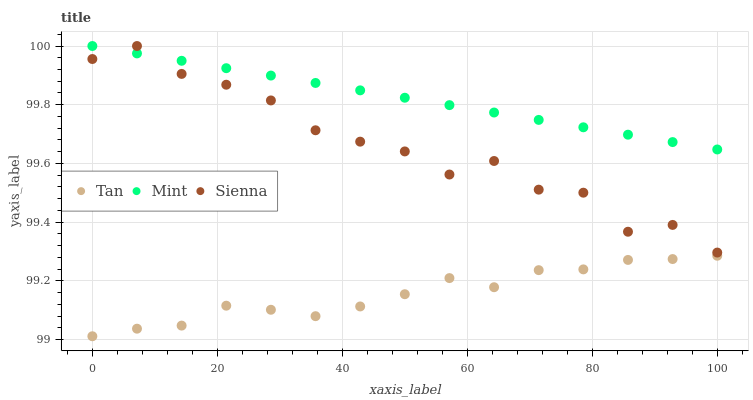Does Tan have the minimum area under the curve?
Answer yes or no. Yes. Does Mint have the maximum area under the curve?
Answer yes or no. Yes. Does Mint have the minimum area under the curve?
Answer yes or no. No. Does Tan have the maximum area under the curve?
Answer yes or no. No. Is Mint the smoothest?
Answer yes or no. Yes. Is Sienna the roughest?
Answer yes or no. Yes. Is Tan the smoothest?
Answer yes or no. No. Is Tan the roughest?
Answer yes or no. No. Does Tan have the lowest value?
Answer yes or no. Yes. Does Mint have the lowest value?
Answer yes or no. No. Does Mint have the highest value?
Answer yes or no. Yes. Does Tan have the highest value?
Answer yes or no. No. Is Tan less than Sienna?
Answer yes or no. Yes. Is Mint greater than Tan?
Answer yes or no. Yes. Does Sienna intersect Mint?
Answer yes or no. Yes. Is Sienna less than Mint?
Answer yes or no. No. Is Sienna greater than Mint?
Answer yes or no. No. Does Tan intersect Sienna?
Answer yes or no. No. 